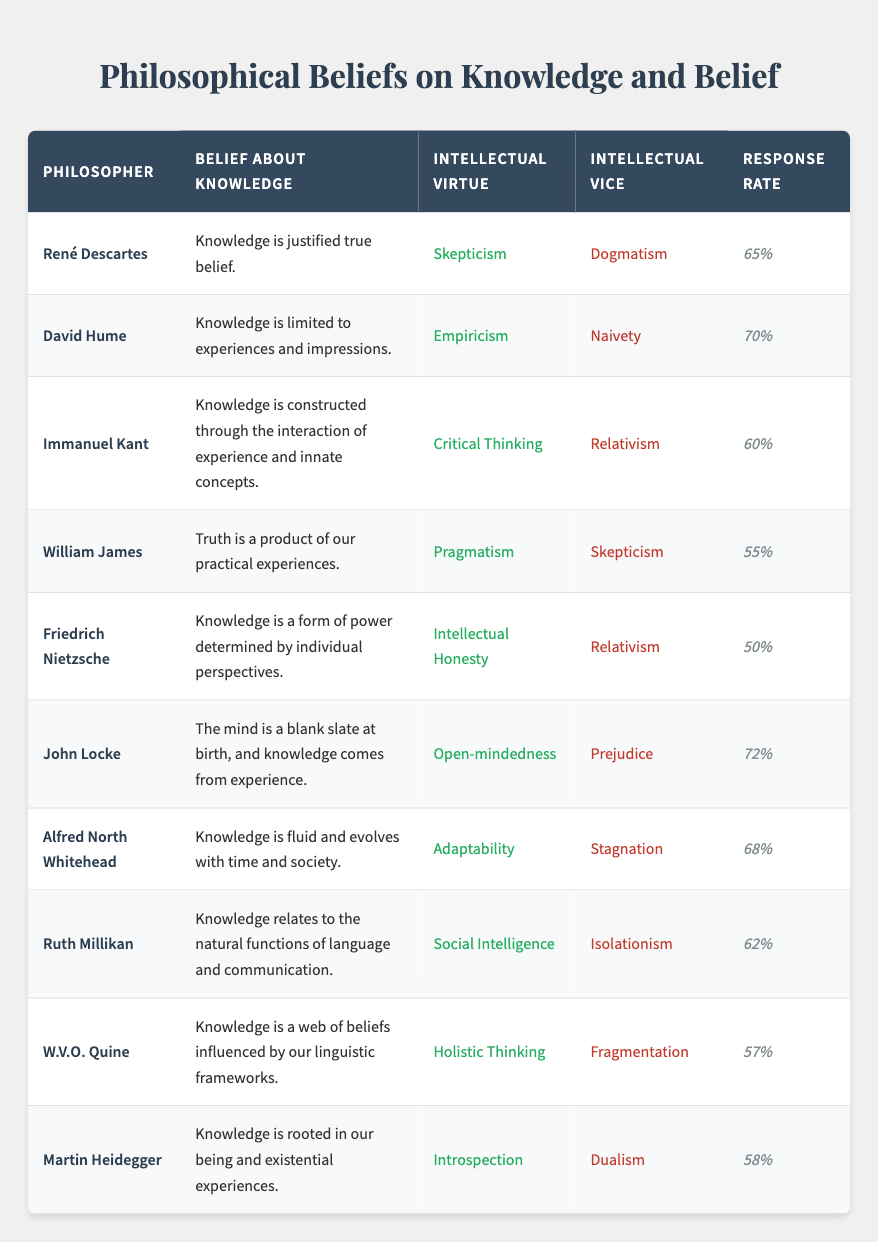What is David Hume's belief about knowledge? According to the table, David Hume believes that "Knowledge is limited to experiences and impressions."
Answer: Knowledge is limited to experiences and impressions Which philosopher has the highest response rate? By examining the response rates in the table, John Locke has the highest response rate of 0.72.
Answer: John Locke Is Immanuel Kant's intellectual virtue critical thinking? The table indicates that Immanuel Kant's intellectual virtue is indeed classified as "Critical Thinking."
Answer: Yes Calculate the average response rate for all philosophers listed. First, we sum up all the response rates: 0.65 + 0.70 + 0.60 + 0.55 + 0.50 + 0.72 + 0.68 + 0.62 + 0.57 + 0.58 = 6.17. Then, we divide by the number of philosophers (10). The average response rate is 6.17 / 10 = 0.617.
Answer: 0.617 What percentage of philosophers have "Relativism" as an intellectual vice? In the table, two philosophers—Immanuel Kant and Friedrich Nietzsche—list "Relativism" as their intellectual vice. Since there are 10 philosophers, we calculate the percentage: (2/10) * 100 = 20%.
Answer: 20% Which philosopher's belief involves the concept of knowledge fluidity? The table shows that Alfred North Whitehead's belief is "Knowledge is fluid and evolves with time and society."
Answer: Alfred North Whitehead Can we find any philosopher whose intellectual virtue is skepticism? The table lists René Descartes and William James among philosophers with "Skepticism" as their intellectual virtue.
Answer: Yes Identify the philosopher associated with the belief that knowledge is constructed through experience and innate concepts. The table clearly states that Immanuel Kant holds this view with the belief: "Knowledge is constructed through the interaction of experience and innate concepts."
Answer: Immanuel Kant 